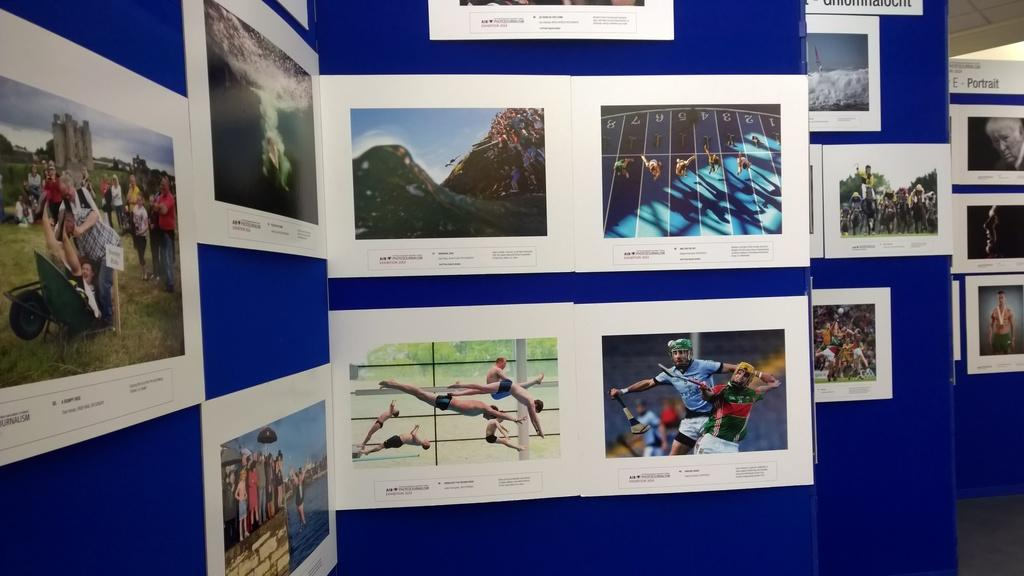What is the color of the surface where the photographs are attached in the image? The surface is blue. What types of images can be seen in the photographs? The photographs contain images of people, mountains, water, and the sky. What type of fuel is being used to power the society depicted in the photographs? There is no information about society or fuel in the image, as it only contains photographs with various images. 